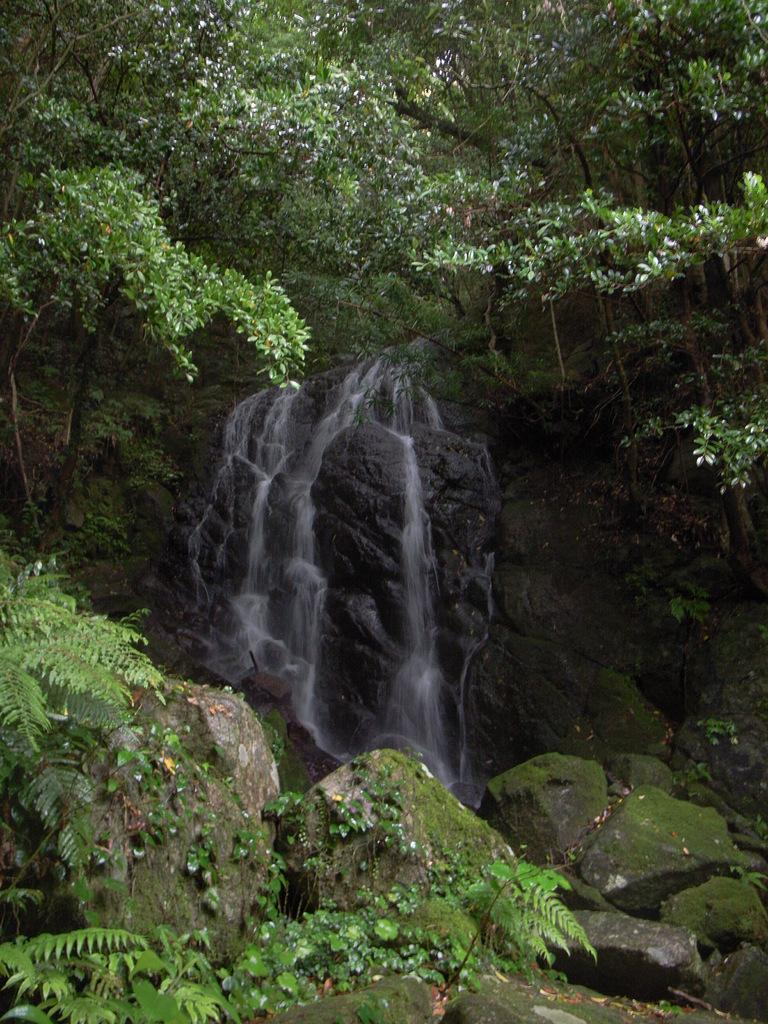What type of natural feature can be seen in the image? There is a river in the image. What other geographical feature is present in the image? There is a mountain in the image. What type of vegetation can be seen in the image? There are trees in the image. What type of grape is being used to read history in the image? There is no grape or history book present in the image; it features a river, a mountain, and trees. 